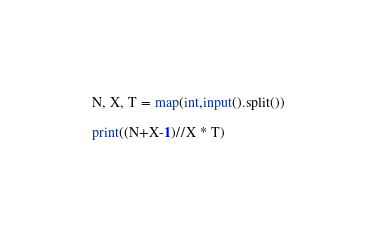<code> <loc_0><loc_0><loc_500><loc_500><_Python_>N, X, T = map(int,input().split())

print((N+X-1)//X * T)</code> 